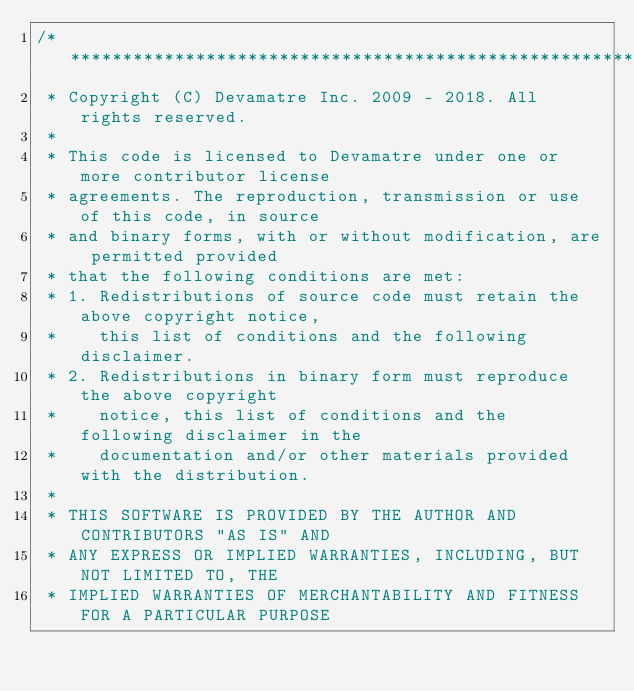Convert code to text. <code><loc_0><loc_0><loc_500><loc_500><_Java_>/******************************************************************************
 * Copyright (C) Devamatre Inc. 2009 - 2018. All rights reserved.
 * 
 * This code is licensed to Devamatre under one or more contributor license 
 * agreements. The reproduction, transmission or use of this code, in source 
 * and binary forms, with or without modification, are permitted provided 
 * that the following conditions are met:
 * 1. Redistributions of source code must retain the above copyright notice, 
 * 	  this list of conditions and the following disclaimer.
 * 2. Redistributions in binary form must reproduce the above copyright
 *    notice, this list of conditions and the following disclaimer in the
 *    documentation and/or other materials provided with the distribution.
 * 
 * THIS SOFTWARE IS PROVIDED BY THE AUTHOR AND CONTRIBUTORS "AS IS" AND
 * ANY EXPRESS OR IMPLIED WARRANTIES, INCLUDING, BUT NOT LIMITED TO, THE
 * IMPLIED WARRANTIES OF MERCHANTABILITY AND FITNESS FOR A PARTICULAR PURPOSE</code> 